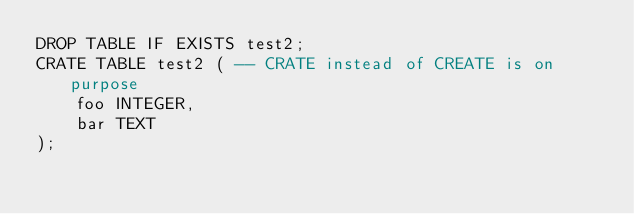<code> <loc_0><loc_0><loc_500><loc_500><_SQL_>DROP TABLE IF EXISTS test2; 
CRATE TABLE test2 ( -- CRATE instead of CREATE is on purpose
    foo INTEGER,
    bar TEXT
);
</code> 